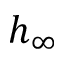Convert formula to latex. <formula><loc_0><loc_0><loc_500><loc_500>h _ { \infty }</formula> 